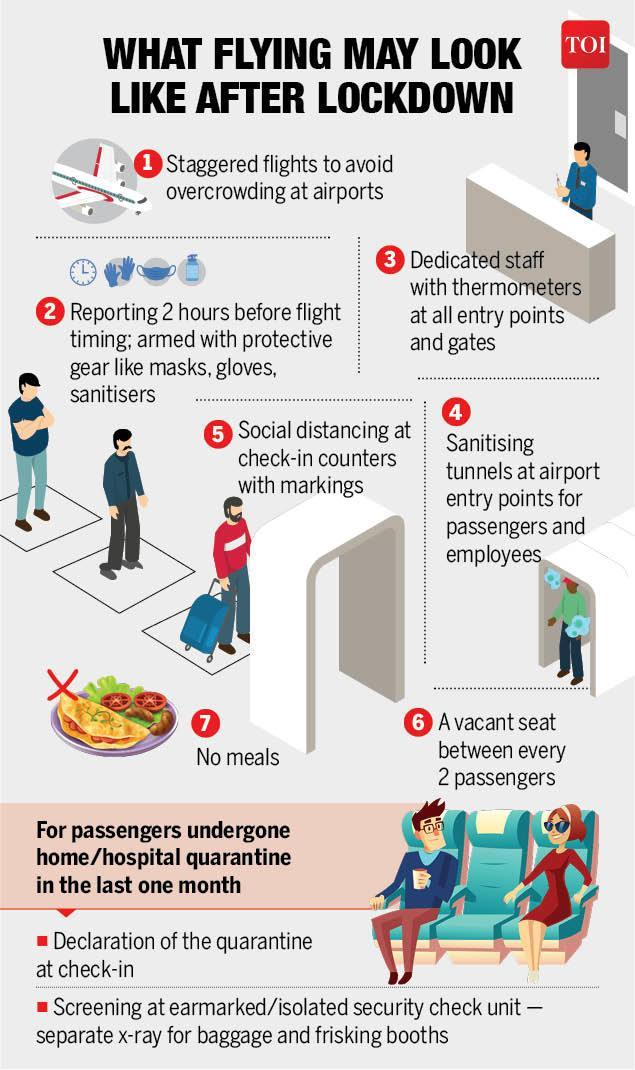How many people are shown in the infographic?
Answer the question with a short phrase. 7 